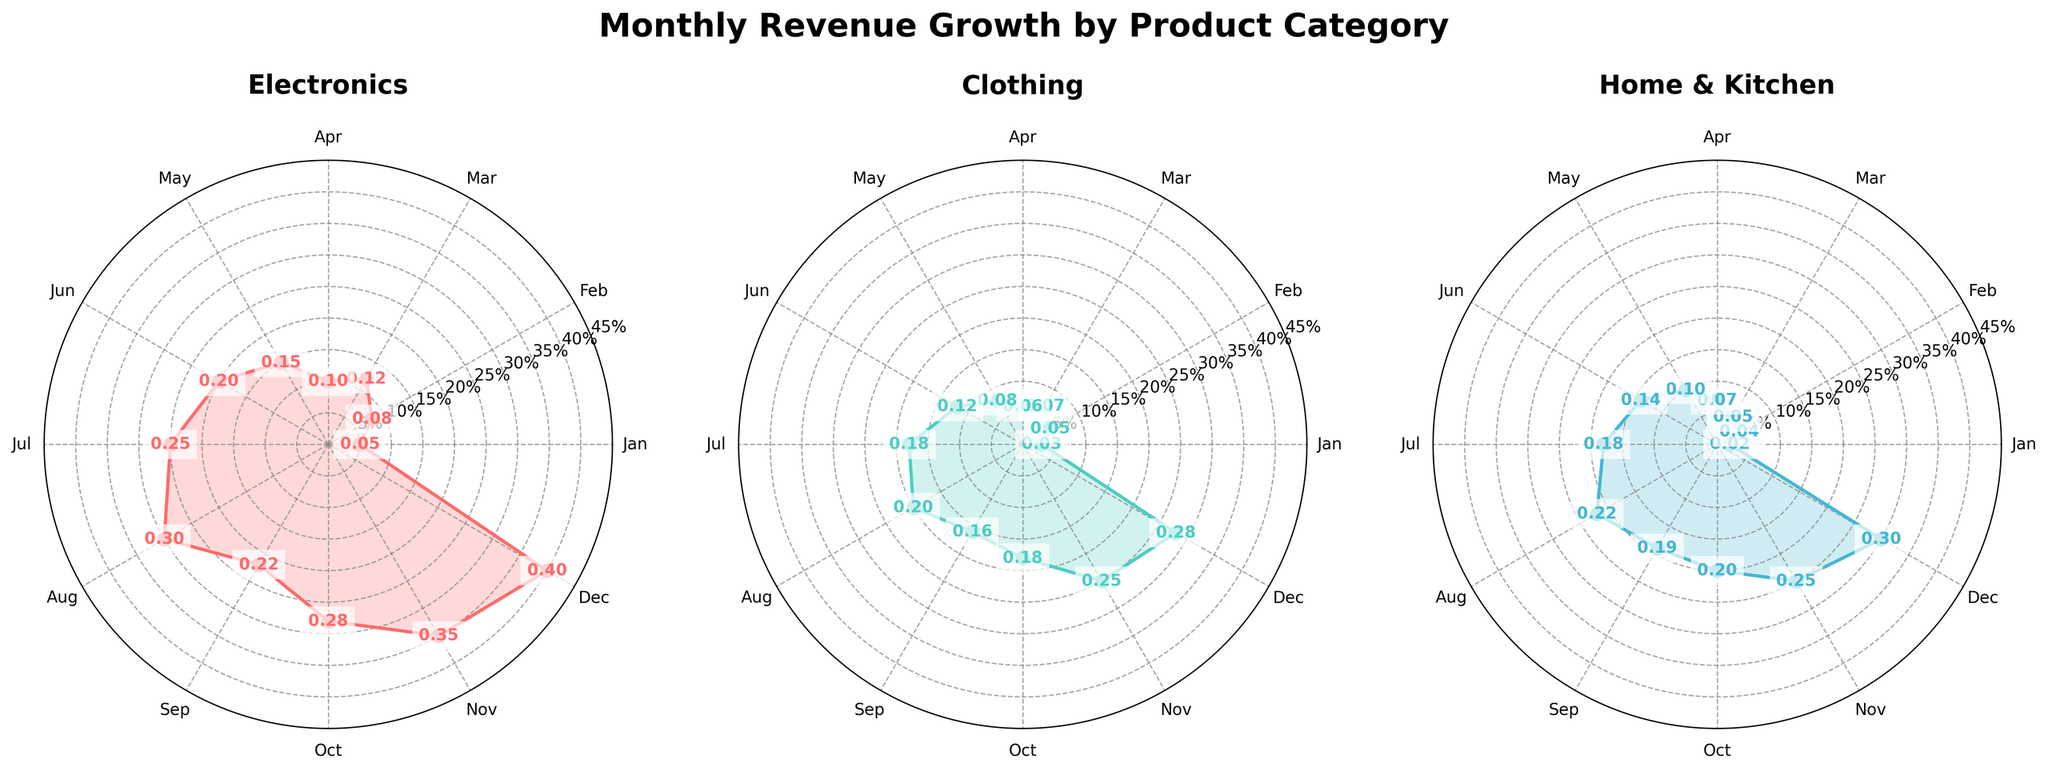What is the title of the figure? The title of the figure is displayed at the top and reads "Monthly Revenue Growth by Product Category."
Answer: Monthly Revenue Growth by Product Category How many product categories are shown in the figure? The figure contains three subplots, each representing a different product category: Electronics, Clothing, and Home & Kitchen.
Answer: 3 What color is used to represent the Electronics category? The Electronics category is represented by a color that looks like a shade of red.
Answer: Red Which month has the highest revenue growth for the Clothing category? In the subplot for Clothing, the December data point is the highest, indicating that December has the highest revenue growth for the Clothing category.
Answer: December What is the revenue growth percentage for Electronics in June? The subplot for Electronics shows a data point labeled 0.20 for June, indicating the revenue growth percentage.
Answer: 20% What is the average revenue growth for the Home & Kitchen category from January to December? To find the average, add the monthly revenue growth values (0.02, 0.04, 0.05, 0.07, 0.10, 0.14, 0.18, 0.22, 0.19, 0.20, 0.25, 0.30) which totals 1.76, then divide by 12 months. The average revenue growth is 1.76/12.
Answer: 0.1467 In which month do all three categories see an increase in revenue growth? All three subplots show an increase in revenue growth in June compared to the previous months.
Answer: June Which product category has the most consistent revenue growth throughout the year? By looking at the variation of the lines, Home & Kitchen seems to have the least fluctuation in its revenue growth, indicating more consistency.
Answer: Home & Kitchen How does the November revenue growth for Clothing compare to Electronics? The November revenue growth for Clothing is shown as 0.25, while for Electronics, it is 0.35. Electronics has a higher revenue growth in November.
Answer: Electronics What is the total revenue growth for Electronics from July to September? To find the total, add the revenue growth values for Electronics from July (0.25), August (0.30), and September (0.22). Sum: 0.25 + 0.30 + 0.22 = 0.77.
Answer: 0.77 